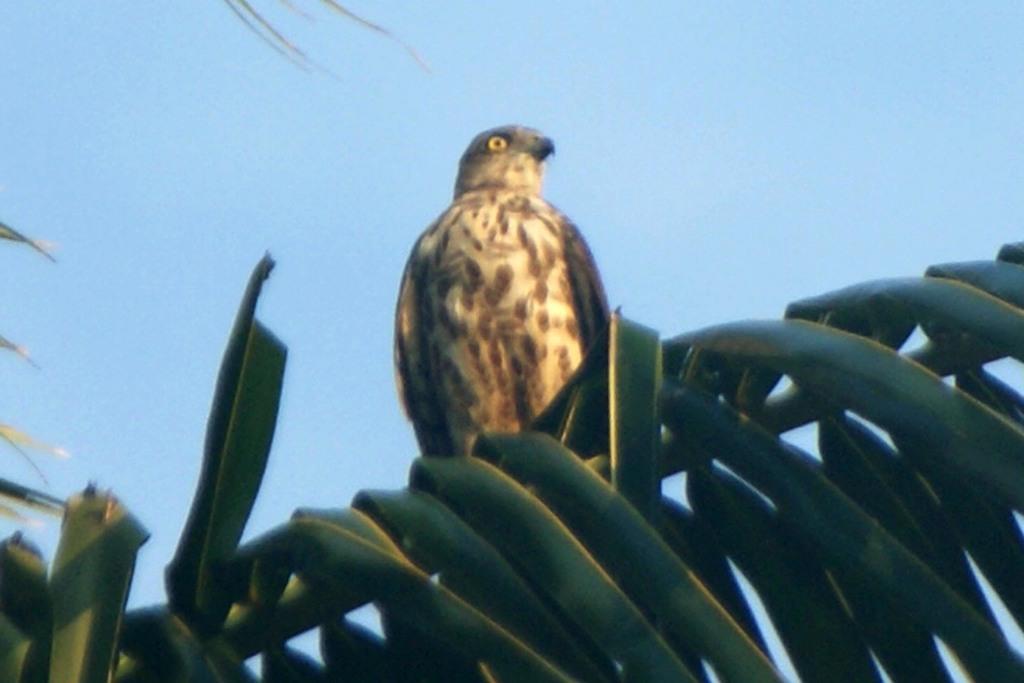Can you describe this image briefly? On these leaves there is a bird. Sky is in blue color. 